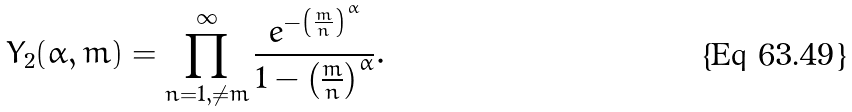Convert formula to latex. <formula><loc_0><loc_0><loc_500><loc_500>Y _ { 2 } ( \alpha , m ) = \prod _ { n = 1 , \ne m } ^ { \infty } \frac { e ^ { - \left ( \frac { m } { n } \right ) ^ { \alpha } } } { 1 - \left ( \frac { m } { n } \right ) ^ { \alpha } } .</formula> 